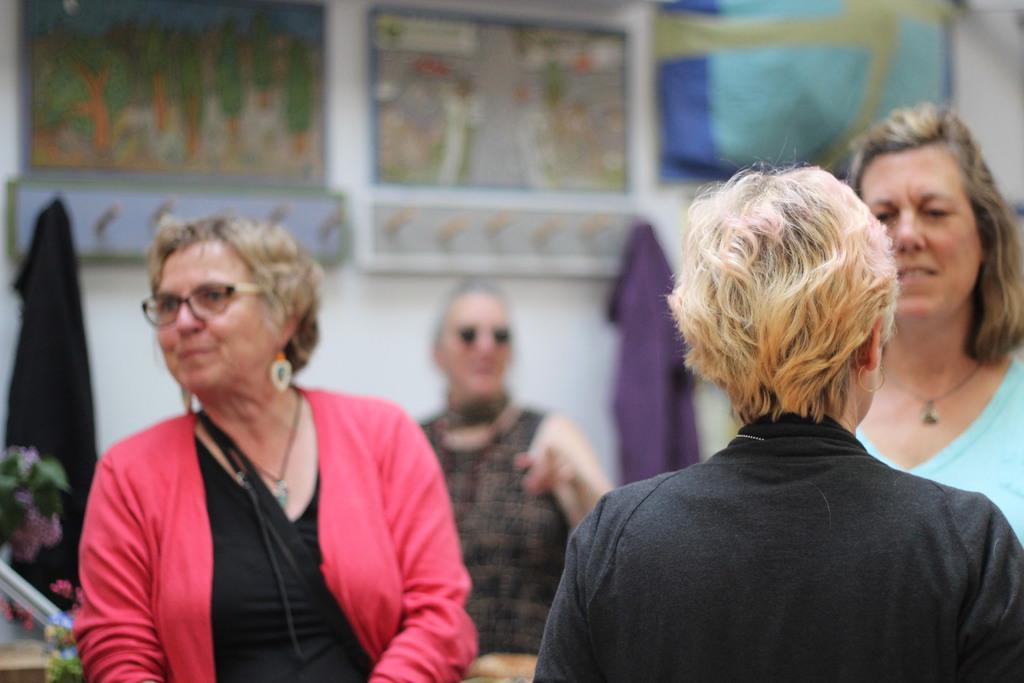Describe this image in one or two sentences. In this image I can see group of people. In front the person is wearing black color dress. In the background I can see few frames attached to the wall and the wall is in white color. 